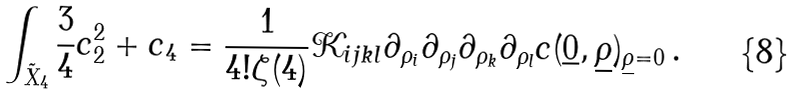Convert formula to latex. <formula><loc_0><loc_0><loc_500><loc_500>\int _ { \tilde { X } _ { 4 } } \frac { 3 } { 4 } c _ { 2 } ^ { 2 } + c _ { 4 } = \frac { 1 } { 4 ! \zeta ( 4 ) } \mathcal { K } _ { i j k l } \partial _ { \rho _ { i } } \partial _ { \rho _ { j } } \partial _ { \rho _ { k } } \partial _ { \rho _ { l } } c ( { \underline { 0 } } , { \underline { \rho } } ) _ { { \underline { \rho } } = 0 } \, .</formula> 